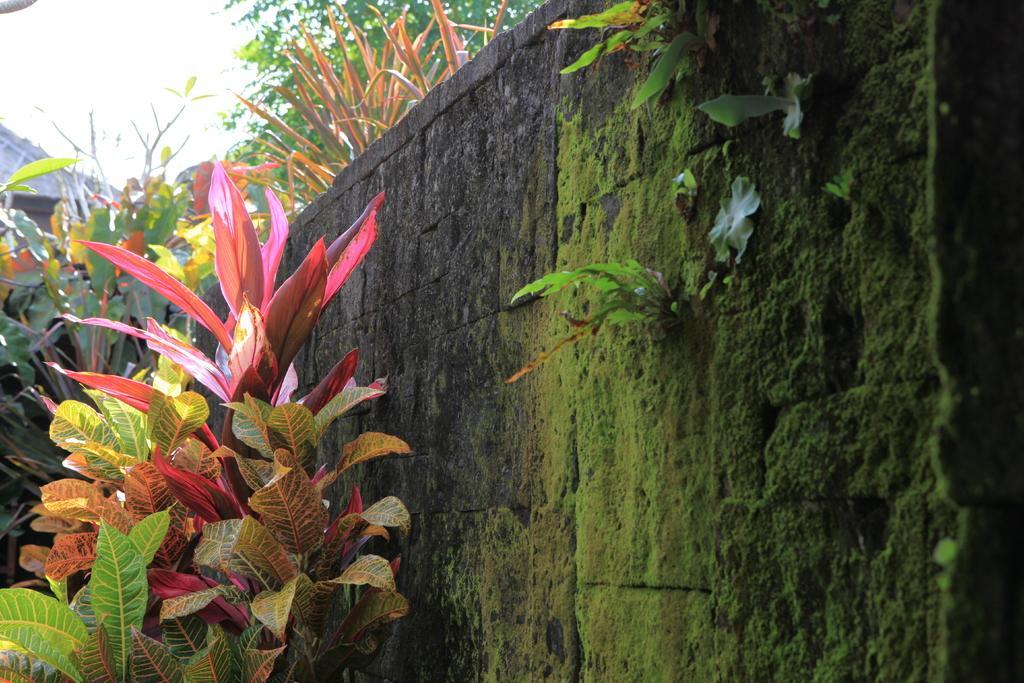Describe this image in one or two sentences. In this image, we can see the wall with some algae. There are a few plants and trees. We can also see the sky. 